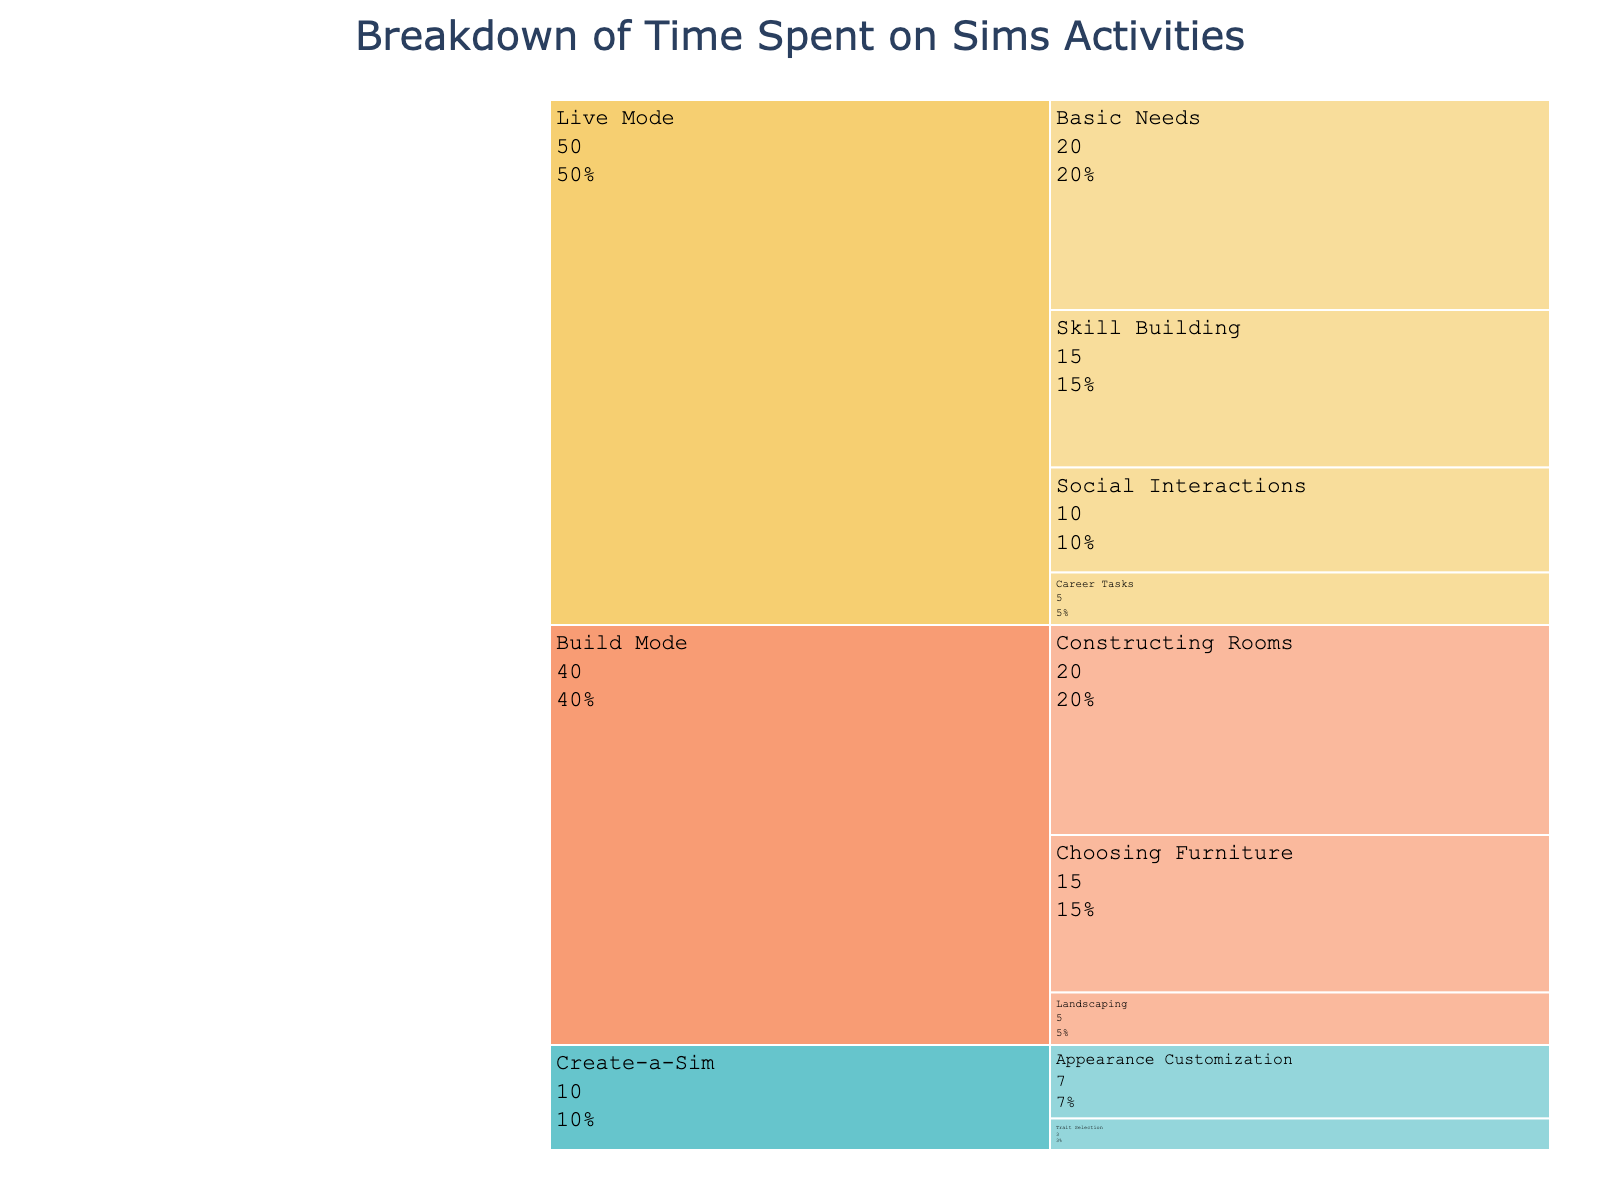What is the title of the icicle chart? The title of the chart is displayed prominently at the top. Reading it helps identify the main focus of the figure.
Answer: Breakdown of Time Spent on Sims Activities What are the three main activities in the chart? The main activities are shown at the first hierarchical level in the icicle chart. They are distinguished by different colors and labels.
Answer: Build Mode, Live Mode, Create-a-Sim What percentage of time is spent on Choosing Furniture within Build Mode? First, locate Build Mode and its subdivisions. Then find Choosing Furniture and observe the percentage displayed next to it.
Answer: 37.5% How much time in total is spent on Career Tasks, Appearance Customization, and Social Interactions? Identify each sub-activity: Career Tasks (5 minutes), Appearance Customization (7 minutes), and Social Interactions (10 minutes). Sum these values: 5 + 7 + 10 = 22 minutes.
Answer: 22 minutes Which sub-activity under Live Mode takes up the most time? Look under the Live Mode section and compare the times for Basic Needs, Skill Building, Social Interactions, and Career Tasks.
Answer: Basic Needs Compare the time spent on Landscaping and Trait Selection. Which one is higher and by how much? Identify the time for Landscaping (5 minutes) and Trait Selection (3 minutes). Subtract the smaller from the larger value: 5 - 3 = 2 minutes.
Answer: Landscaping by 2 minutes How much more time is spent on Basic Needs compared to Constructing Rooms? Find the times for Basic Needs (20 minutes) and Constructing Rooms (20 minutes). Subtract Constructing Rooms from Basic Needs: 20 - 20 = 0 minutes.
Answer: Same amount of time Of the total time spent on Build Mode, what fraction is spent on Landscaping? Total time for Build Mode is 40 minutes. Time spent on Landscaping is 5 minutes. Fraction is calculated as 5/40 = 1/8.
Answer: 1/8 Overall, which activity occupies the least amount of time in the chart? Compare the total time of the main activities: Build Mode (40 minutes), Live Mode (50 minutes), and Create-a-Sim (10 minutes). The least is 10 minutes.
Answer: Create-a-Sim What sub-activity contributes the least time overall and under which main activity does it fall? Scan all sub-activities and identify the lowest value, which is Career Tasks at 5 minutes under Live Mode.
Answer: Career Tasks under Live Mode 